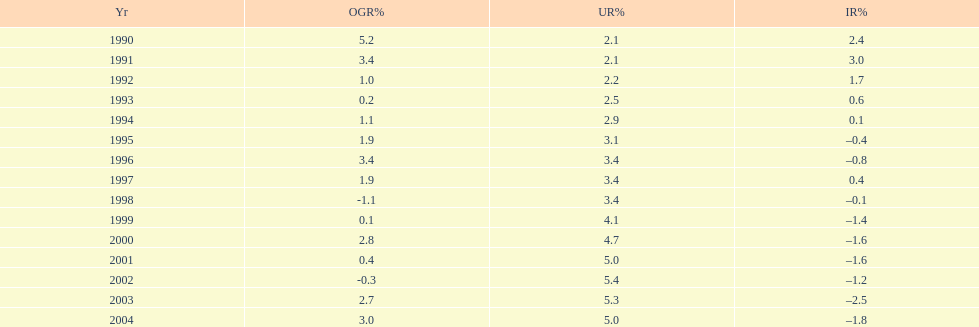When in the 1990's did the inflation rate first become negative? 1995. 